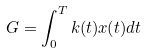Convert formula to latex. <formula><loc_0><loc_0><loc_500><loc_500>G = \int _ { 0 } ^ { T } k ( t ) x ( t ) d t</formula> 